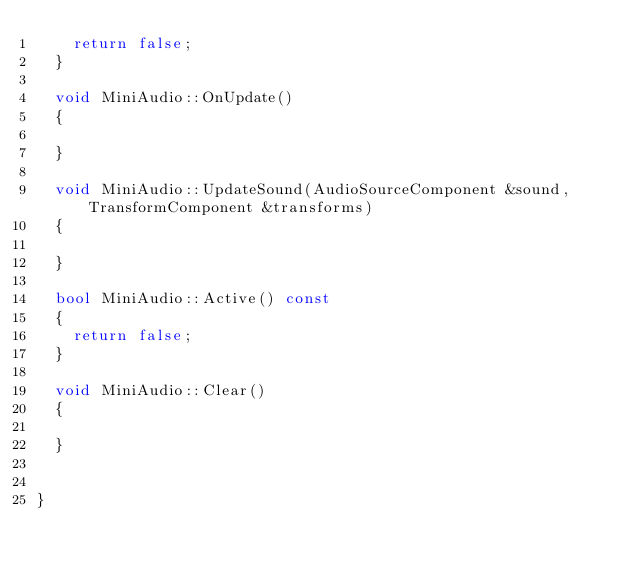Convert code to text. <code><loc_0><loc_0><loc_500><loc_500><_C++_>		return false;
	}

	void MiniAudio::OnUpdate()
	{

	}

	void MiniAudio::UpdateSound(AudioSourceComponent &sound, TransformComponent &transforms)
	{

	}

	bool MiniAudio::Active() const
	{
		return false;
	}

	void MiniAudio::Clear()
	{

	}


}</code> 